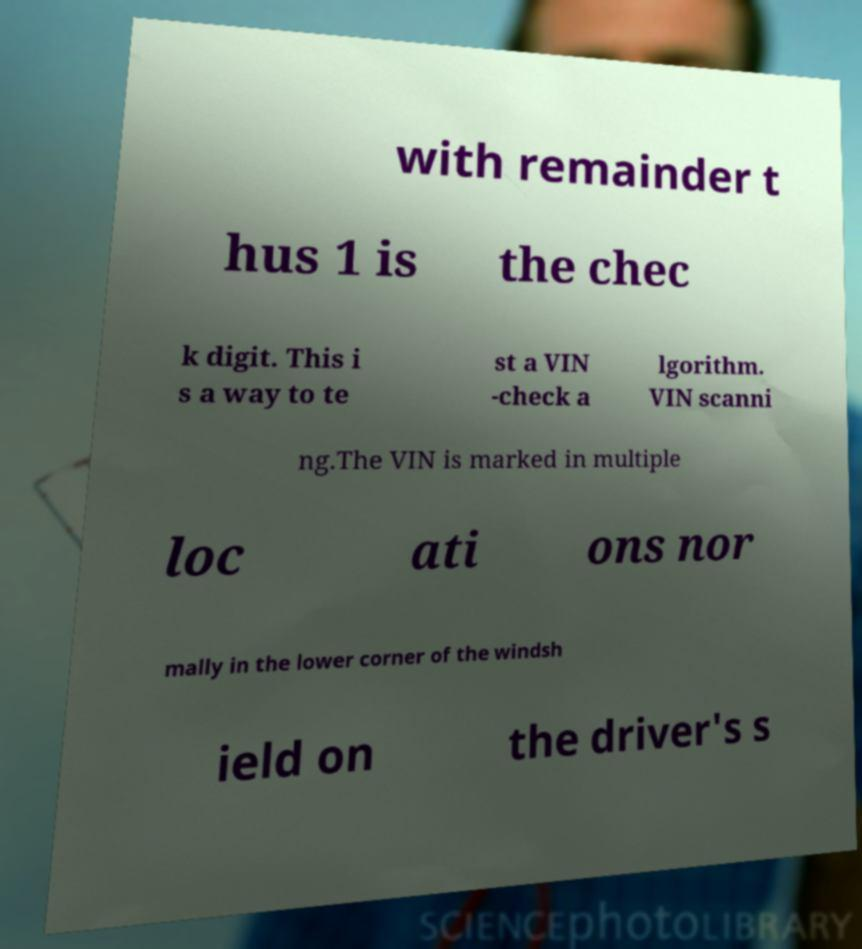What messages or text are displayed in this image? I need them in a readable, typed format. with remainder t hus 1 is the chec k digit. This i s a way to te st a VIN -check a lgorithm. VIN scanni ng.The VIN is marked in multiple loc ati ons nor mally in the lower corner of the windsh ield on the driver's s 